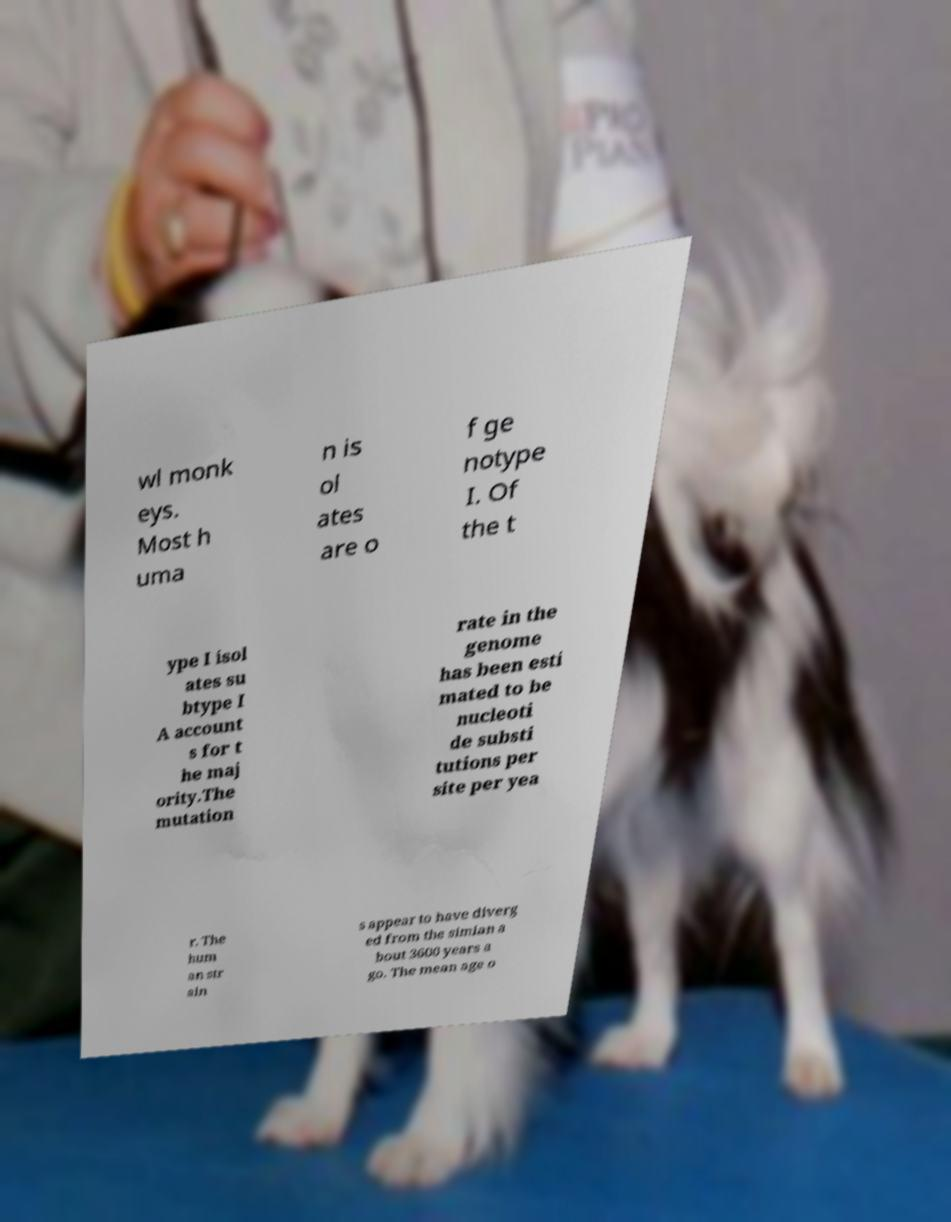What messages or text are displayed in this image? I need them in a readable, typed format. wl monk eys. Most h uma n is ol ates are o f ge notype I. Of the t ype I isol ates su btype I A account s for t he maj ority.The mutation rate in the genome has been esti mated to be nucleoti de substi tutions per site per yea r. The hum an str ain s appear to have diverg ed from the simian a bout 3600 years a go. The mean age o 